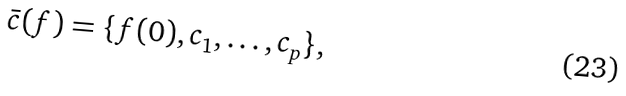<formula> <loc_0><loc_0><loc_500><loc_500>\bar { c } ( f ) = \{ f ( 0 ) , c _ { 1 } , \dots , c _ { p } \} ,</formula> 